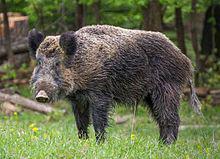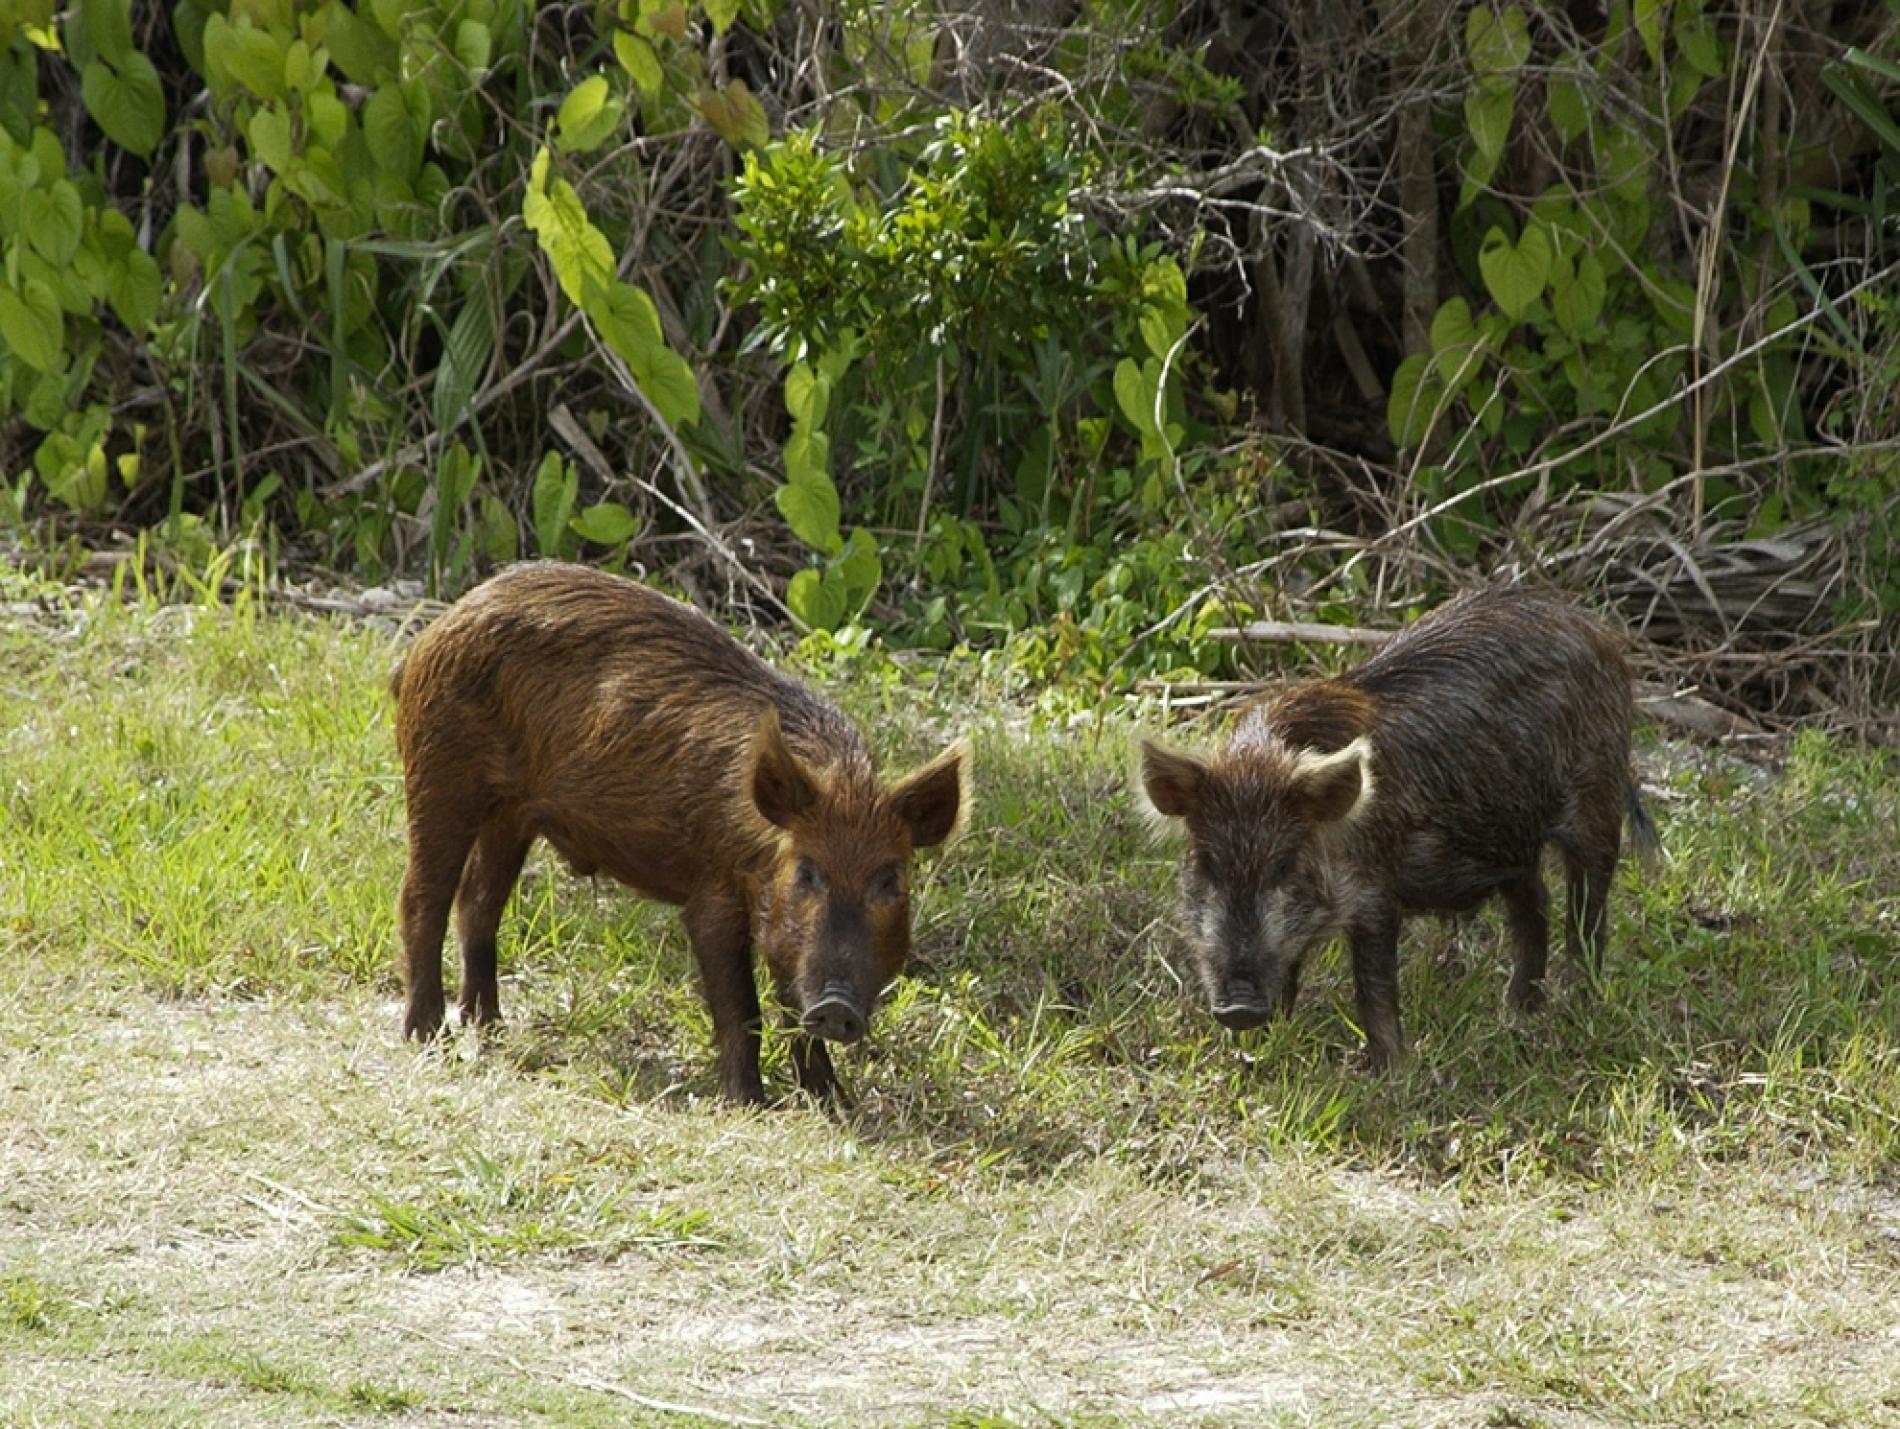The first image is the image on the left, the second image is the image on the right. For the images displayed, is the sentence "The right image contains exactly two boars." factually correct? Answer yes or no. Yes. 